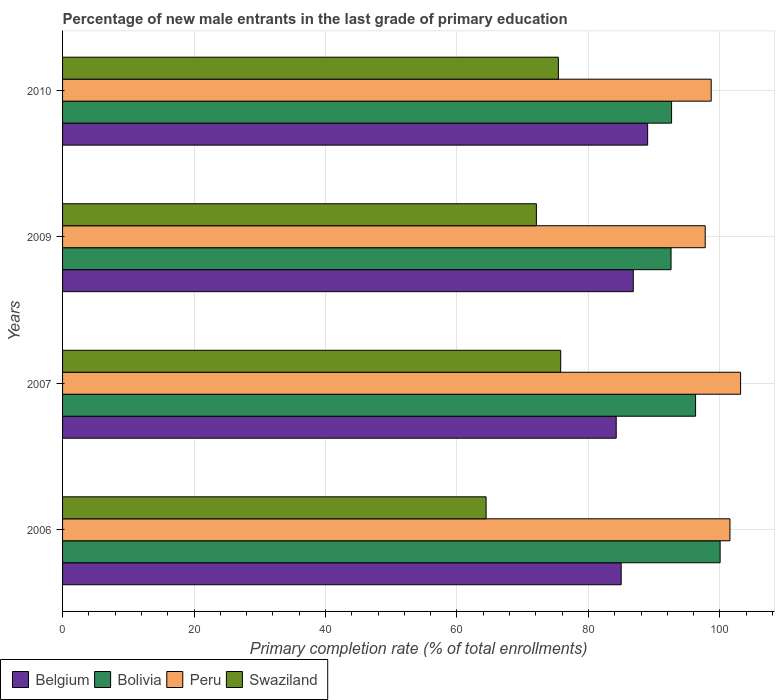How many bars are there on the 1st tick from the top?
Keep it short and to the point. 4. In how many cases, is the number of bars for a given year not equal to the number of legend labels?
Your response must be concise. 0. What is the percentage of new male entrants in Belgium in 2007?
Make the answer very short. 84.23. Across all years, what is the maximum percentage of new male entrants in Swaziland?
Provide a short and direct response. 75.78. Across all years, what is the minimum percentage of new male entrants in Swaziland?
Offer a very short reply. 64.43. What is the total percentage of new male entrants in Bolivia in the graph?
Make the answer very short. 381.57. What is the difference between the percentage of new male entrants in Swaziland in 2006 and that in 2010?
Keep it short and to the point. -11. What is the difference between the percentage of new male entrants in Swaziland in 2010 and the percentage of new male entrants in Belgium in 2009?
Offer a very short reply. -11.4. What is the average percentage of new male entrants in Swaziland per year?
Ensure brevity in your answer.  71.93. In the year 2006, what is the difference between the percentage of new male entrants in Bolivia and percentage of new male entrants in Swaziland?
Your answer should be compact. 35.61. What is the ratio of the percentage of new male entrants in Bolivia in 2007 to that in 2010?
Ensure brevity in your answer.  1.04. Is the percentage of new male entrants in Belgium in 2007 less than that in 2009?
Offer a terse response. Yes. What is the difference between the highest and the second highest percentage of new male entrants in Belgium?
Provide a short and direct response. 2.19. What is the difference between the highest and the lowest percentage of new male entrants in Peru?
Provide a succinct answer. 5.38. In how many years, is the percentage of new male entrants in Swaziland greater than the average percentage of new male entrants in Swaziland taken over all years?
Your response must be concise. 3. What does the 1st bar from the top in 2009 represents?
Ensure brevity in your answer.  Swaziland. Is it the case that in every year, the sum of the percentage of new male entrants in Belgium and percentage of new male entrants in Peru is greater than the percentage of new male entrants in Swaziland?
Offer a very short reply. Yes. Are all the bars in the graph horizontal?
Ensure brevity in your answer.  Yes. What is the difference between two consecutive major ticks on the X-axis?
Your answer should be compact. 20. How many legend labels are there?
Your answer should be very brief. 4. What is the title of the graph?
Your answer should be compact. Percentage of new male entrants in the last grade of primary education. Does "French Polynesia" appear as one of the legend labels in the graph?
Give a very brief answer. No. What is the label or title of the X-axis?
Offer a very short reply. Primary completion rate (% of total enrollments). What is the label or title of the Y-axis?
Offer a terse response. Years. What is the Primary completion rate (% of total enrollments) in Belgium in 2006?
Your response must be concise. 84.99. What is the Primary completion rate (% of total enrollments) in Bolivia in 2006?
Offer a very short reply. 100.04. What is the Primary completion rate (% of total enrollments) of Peru in 2006?
Provide a succinct answer. 101.53. What is the Primary completion rate (% of total enrollments) of Swaziland in 2006?
Offer a terse response. 64.43. What is the Primary completion rate (% of total enrollments) in Belgium in 2007?
Keep it short and to the point. 84.23. What is the Primary completion rate (% of total enrollments) in Bolivia in 2007?
Your response must be concise. 96.3. What is the Primary completion rate (% of total enrollments) in Peru in 2007?
Your response must be concise. 103.15. What is the Primary completion rate (% of total enrollments) of Swaziland in 2007?
Your response must be concise. 75.78. What is the Primary completion rate (% of total enrollments) in Belgium in 2009?
Offer a terse response. 86.83. What is the Primary completion rate (% of total enrollments) of Bolivia in 2009?
Your answer should be compact. 92.57. What is the Primary completion rate (% of total enrollments) in Peru in 2009?
Ensure brevity in your answer.  97.77. What is the Primary completion rate (% of total enrollments) in Swaziland in 2009?
Offer a terse response. 72.08. What is the Primary completion rate (% of total enrollments) in Belgium in 2010?
Keep it short and to the point. 89.01. What is the Primary completion rate (% of total enrollments) of Bolivia in 2010?
Your answer should be compact. 92.65. What is the Primary completion rate (% of total enrollments) in Peru in 2010?
Your answer should be compact. 98.68. What is the Primary completion rate (% of total enrollments) in Swaziland in 2010?
Your answer should be very brief. 75.43. Across all years, what is the maximum Primary completion rate (% of total enrollments) of Belgium?
Offer a very short reply. 89.01. Across all years, what is the maximum Primary completion rate (% of total enrollments) of Bolivia?
Provide a short and direct response. 100.04. Across all years, what is the maximum Primary completion rate (% of total enrollments) in Peru?
Offer a terse response. 103.15. Across all years, what is the maximum Primary completion rate (% of total enrollments) in Swaziland?
Offer a terse response. 75.78. Across all years, what is the minimum Primary completion rate (% of total enrollments) of Belgium?
Your answer should be very brief. 84.23. Across all years, what is the minimum Primary completion rate (% of total enrollments) of Bolivia?
Give a very brief answer. 92.57. Across all years, what is the minimum Primary completion rate (% of total enrollments) of Peru?
Offer a terse response. 97.77. Across all years, what is the minimum Primary completion rate (% of total enrollments) in Swaziland?
Provide a succinct answer. 64.43. What is the total Primary completion rate (% of total enrollments) of Belgium in the graph?
Provide a succinct answer. 345.06. What is the total Primary completion rate (% of total enrollments) in Bolivia in the graph?
Ensure brevity in your answer.  381.56. What is the total Primary completion rate (% of total enrollments) of Peru in the graph?
Provide a succinct answer. 401.13. What is the total Primary completion rate (% of total enrollments) in Swaziland in the graph?
Give a very brief answer. 287.73. What is the difference between the Primary completion rate (% of total enrollments) of Belgium in 2006 and that in 2007?
Make the answer very short. 0.76. What is the difference between the Primary completion rate (% of total enrollments) of Bolivia in 2006 and that in 2007?
Your answer should be very brief. 3.74. What is the difference between the Primary completion rate (% of total enrollments) in Peru in 2006 and that in 2007?
Your answer should be very brief. -1.62. What is the difference between the Primary completion rate (% of total enrollments) in Swaziland in 2006 and that in 2007?
Ensure brevity in your answer.  -11.35. What is the difference between the Primary completion rate (% of total enrollments) in Belgium in 2006 and that in 2009?
Your response must be concise. -1.84. What is the difference between the Primary completion rate (% of total enrollments) of Bolivia in 2006 and that in 2009?
Make the answer very short. 7.47. What is the difference between the Primary completion rate (% of total enrollments) of Peru in 2006 and that in 2009?
Your answer should be compact. 3.76. What is the difference between the Primary completion rate (% of total enrollments) of Swaziland in 2006 and that in 2009?
Make the answer very short. -7.65. What is the difference between the Primary completion rate (% of total enrollments) of Belgium in 2006 and that in 2010?
Ensure brevity in your answer.  -4.03. What is the difference between the Primary completion rate (% of total enrollments) of Bolivia in 2006 and that in 2010?
Your answer should be very brief. 7.39. What is the difference between the Primary completion rate (% of total enrollments) of Peru in 2006 and that in 2010?
Offer a very short reply. 2.85. What is the difference between the Primary completion rate (% of total enrollments) in Swaziland in 2006 and that in 2010?
Keep it short and to the point. -11. What is the difference between the Primary completion rate (% of total enrollments) of Belgium in 2007 and that in 2009?
Your answer should be compact. -2.59. What is the difference between the Primary completion rate (% of total enrollments) in Bolivia in 2007 and that in 2009?
Keep it short and to the point. 3.73. What is the difference between the Primary completion rate (% of total enrollments) of Peru in 2007 and that in 2009?
Your answer should be compact. 5.38. What is the difference between the Primary completion rate (% of total enrollments) of Swaziland in 2007 and that in 2009?
Offer a very short reply. 3.7. What is the difference between the Primary completion rate (% of total enrollments) of Belgium in 2007 and that in 2010?
Provide a short and direct response. -4.78. What is the difference between the Primary completion rate (% of total enrollments) of Bolivia in 2007 and that in 2010?
Offer a very short reply. 3.65. What is the difference between the Primary completion rate (% of total enrollments) in Peru in 2007 and that in 2010?
Your answer should be very brief. 4.47. What is the difference between the Primary completion rate (% of total enrollments) of Swaziland in 2007 and that in 2010?
Keep it short and to the point. 0.35. What is the difference between the Primary completion rate (% of total enrollments) in Belgium in 2009 and that in 2010?
Give a very brief answer. -2.19. What is the difference between the Primary completion rate (% of total enrollments) of Bolivia in 2009 and that in 2010?
Offer a terse response. -0.08. What is the difference between the Primary completion rate (% of total enrollments) of Peru in 2009 and that in 2010?
Your answer should be compact. -0.91. What is the difference between the Primary completion rate (% of total enrollments) of Swaziland in 2009 and that in 2010?
Your response must be concise. -3.35. What is the difference between the Primary completion rate (% of total enrollments) of Belgium in 2006 and the Primary completion rate (% of total enrollments) of Bolivia in 2007?
Your response must be concise. -11.32. What is the difference between the Primary completion rate (% of total enrollments) of Belgium in 2006 and the Primary completion rate (% of total enrollments) of Peru in 2007?
Offer a terse response. -18.17. What is the difference between the Primary completion rate (% of total enrollments) in Belgium in 2006 and the Primary completion rate (% of total enrollments) in Swaziland in 2007?
Provide a succinct answer. 9.2. What is the difference between the Primary completion rate (% of total enrollments) of Bolivia in 2006 and the Primary completion rate (% of total enrollments) of Peru in 2007?
Make the answer very short. -3.11. What is the difference between the Primary completion rate (% of total enrollments) in Bolivia in 2006 and the Primary completion rate (% of total enrollments) in Swaziland in 2007?
Keep it short and to the point. 24.26. What is the difference between the Primary completion rate (% of total enrollments) in Peru in 2006 and the Primary completion rate (% of total enrollments) in Swaziland in 2007?
Keep it short and to the point. 25.75. What is the difference between the Primary completion rate (% of total enrollments) of Belgium in 2006 and the Primary completion rate (% of total enrollments) of Bolivia in 2009?
Give a very brief answer. -7.59. What is the difference between the Primary completion rate (% of total enrollments) in Belgium in 2006 and the Primary completion rate (% of total enrollments) in Peru in 2009?
Offer a terse response. -12.78. What is the difference between the Primary completion rate (% of total enrollments) of Belgium in 2006 and the Primary completion rate (% of total enrollments) of Swaziland in 2009?
Your answer should be compact. 12.9. What is the difference between the Primary completion rate (% of total enrollments) in Bolivia in 2006 and the Primary completion rate (% of total enrollments) in Peru in 2009?
Ensure brevity in your answer.  2.27. What is the difference between the Primary completion rate (% of total enrollments) of Bolivia in 2006 and the Primary completion rate (% of total enrollments) of Swaziland in 2009?
Give a very brief answer. 27.95. What is the difference between the Primary completion rate (% of total enrollments) in Peru in 2006 and the Primary completion rate (% of total enrollments) in Swaziland in 2009?
Offer a very short reply. 29.45. What is the difference between the Primary completion rate (% of total enrollments) of Belgium in 2006 and the Primary completion rate (% of total enrollments) of Bolivia in 2010?
Ensure brevity in your answer.  -7.67. What is the difference between the Primary completion rate (% of total enrollments) of Belgium in 2006 and the Primary completion rate (% of total enrollments) of Peru in 2010?
Your response must be concise. -13.7. What is the difference between the Primary completion rate (% of total enrollments) of Belgium in 2006 and the Primary completion rate (% of total enrollments) of Swaziland in 2010?
Provide a succinct answer. 9.56. What is the difference between the Primary completion rate (% of total enrollments) in Bolivia in 2006 and the Primary completion rate (% of total enrollments) in Peru in 2010?
Ensure brevity in your answer.  1.36. What is the difference between the Primary completion rate (% of total enrollments) in Bolivia in 2006 and the Primary completion rate (% of total enrollments) in Swaziland in 2010?
Keep it short and to the point. 24.61. What is the difference between the Primary completion rate (% of total enrollments) in Peru in 2006 and the Primary completion rate (% of total enrollments) in Swaziland in 2010?
Provide a succinct answer. 26.1. What is the difference between the Primary completion rate (% of total enrollments) in Belgium in 2007 and the Primary completion rate (% of total enrollments) in Bolivia in 2009?
Keep it short and to the point. -8.34. What is the difference between the Primary completion rate (% of total enrollments) in Belgium in 2007 and the Primary completion rate (% of total enrollments) in Peru in 2009?
Your response must be concise. -13.54. What is the difference between the Primary completion rate (% of total enrollments) in Belgium in 2007 and the Primary completion rate (% of total enrollments) in Swaziland in 2009?
Provide a short and direct response. 12.15. What is the difference between the Primary completion rate (% of total enrollments) of Bolivia in 2007 and the Primary completion rate (% of total enrollments) of Peru in 2009?
Your answer should be compact. -1.47. What is the difference between the Primary completion rate (% of total enrollments) in Bolivia in 2007 and the Primary completion rate (% of total enrollments) in Swaziland in 2009?
Ensure brevity in your answer.  24.22. What is the difference between the Primary completion rate (% of total enrollments) of Peru in 2007 and the Primary completion rate (% of total enrollments) of Swaziland in 2009?
Make the answer very short. 31.07. What is the difference between the Primary completion rate (% of total enrollments) in Belgium in 2007 and the Primary completion rate (% of total enrollments) in Bolivia in 2010?
Ensure brevity in your answer.  -8.42. What is the difference between the Primary completion rate (% of total enrollments) in Belgium in 2007 and the Primary completion rate (% of total enrollments) in Peru in 2010?
Offer a terse response. -14.45. What is the difference between the Primary completion rate (% of total enrollments) in Belgium in 2007 and the Primary completion rate (% of total enrollments) in Swaziland in 2010?
Keep it short and to the point. 8.8. What is the difference between the Primary completion rate (% of total enrollments) of Bolivia in 2007 and the Primary completion rate (% of total enrollments) of Peru in 2010?
Offer a very short reply. -2.38. What is the difference between the Primary completion rate (% of total enrollments) of Bolivia in 2007 and the Primary completion rate (% of total enrollments) of Swaziland in 2010?
Your answer should be compact. 20.87. What is the difference between the Primary completion rate (% of total enrollments) of Peru in 2007 and the Primary completion rate (% of total enrollments) of Swaziland in 2010?
Provide a succinct answer. 27.72. What is the difference between the Primary completion rate (% of total enrollments) of Belgium in 2009 and the Primary completion rate (% of total enrollments) of Bolivia in 2010?
Your response must be concise. -5.83. What is the difference between the Primary completion rate (% of total enrollments) of Belgium in 2009 and the Primary completion rate (% of total enrollments) of Peru in 2010?
Provide a short and direct response. -11.86. What is the difference between the Primary completion rate (% of total enrollments) in Belgium in 2009 and the Primary completion rate (% of total enrollments) in Swaziland in 2010?
Keep it short and to the point. 11.4. What is the difference between the Primary completion rate (% of total enrollments) of Bolivia in 2009 and the Primary completion rate (% of total enrollments) of Peru in 2010?
Keep it short and to the point. -6.11. What is the difference between the Primary completion rate (% of total enrollments) of Bolivia in 2009 and the Primary completion rate (% of total enrollments) of Swaziland in 2010?
Give a very brief answer. 17.14. What is the difference between the Primary completion rate (% of total enrollments) of Peru in 2009 and the Primary completion rate (% of total enrollments) of Swaziland in 2010?
Ensure brevity in your answer.  22.34. What is the average Primary completion rate (% of total enrollments) in Belgium per year?
Ensure brevity in your answer.  86.26. What is the average Primary completion rate (% of total enrollments) of Bolivia per year?
Your answer should be very brief. 95.39. What is the average Primary completion rate (% of total enrollments) of Peru per year?
Offer a terse response. 100.28. What is the average Primary completion rate (% of total enrollments) in Swaziland per year?
Provide a short and direct response. 71.93. In the year 2006, what is the difference between the Primary completion rate (% of total enrollments) of Belgium and Primary completion rate (% of total enrollments) of Bolivia?
Offer a terse response. -15.05. In the year 2006, what is the difference between the Primary completion rate (% of total enrollments) in Belgium and Primary completion rate (% of total enrollments) in Peru?
Provide a succinct answer. -16.55. In the year 2006, what is the difference between the Primary completion rate (% of total enrollments) of Belgium and Primary completion rate (% of total enrollments) of Swaziland?
Your answer should be compact. 20.55. In the year 2006, what is the difference between the Primary completion rate (% of total enrollments) in Bolivia and Primary completion rate (% of total enrollments) in Peru?
Provide a short and direct response. -1.49. In the year 2006, what is the difference between the Primary completion rate (% of total enrollments) of Bolivia and Primary completion rate (% of total enrollments) of Swaziland?
Offer a very short reply. 35.61. In the year 2006, what is the difference between the Primary completion rate (% of total enrollments) in Peru and Primary completion rate (% of total enrollments) in Swaziland?
Ensure brevity in your answer.  37.1. In the year 2007, what is the difference between the Primary completion rate (% of total enrollments) in Belgium and Primary completion rate (% of total enrollments) in Bolivia?
Your answer should be compact. -12.07. In the year 2007, what is the difference between the Primary completion rate (% of total enrollments) in Belgium and Primary completion rate (% of total enrollments) in Peru?
Ensure brevity in your answer.  -18.92. In the year 2007, what is the difference between the Primary completion rate (% of total enrollments) of Belgium and Primary completion rate (% of total enrollments) of Swaziland?
Make the answer very short. 8.45. In the year 2007, what is the difference between the Primary completion rate (% of total enrollments) in Bolivia and Primary completion rate (% of total enrollments) in Peru?
Keep it short and to the point. -6.85. In the year 2007, what is the difference between the Primary completion rate (% of total enrollments) in Bolivia and Primary completion rate (% of total enrollments) in Swaziland?
Keep it short and to the point. 20.52. In the year 2007, what is the difference between the Primary completion rate (% of total enrollments) of Peru and Primary completion rate (% of total enrollments) of Swaziland?
Provide a succinct answer. 27.37. In the year 2009, what is the difference between the Primary completion rate (% of total enrollments) in Belgium and Primary completion rate (% of total enrollments) in Bolivia?
Your answer should be very brief. -5.75. In the year 2009, what is the difference between the Primary completion rate (% of total enrollments) in Belgium and Primary completion rate (% of total enrollments) in Peru?
Your answer should be compact. -10.94. In the year 2009, what is the difference between the Primary completion rate (% of total enrollments) of Belgium and Primary completion rate (% of total enrollments) of Swaziland?
Provide a short and direct response. 14.74. In the year 2009, what is the difference between the Primary completion rate (% of total enrollments) of Bolivia and Primary completion rate (% of total enrollments) of Peru?
Give a very brief answer. -5.2. In the year 2009, what is the difference between the Primary completion rate (% of total enrollments) of Bolivia and Primary completion rate (% of total enrollments) of Swaziland?
Your response must be concise. 20.49. In the year 2009, what is the difference between the Primary completion rate (% of total enrollments) of Peru and Primary completion rate (% of total enrollments) of Swaziland?
Your response must be concise. 25.68. In the year 2010, what is the difference between the Primary completion rate (% of total enrollments) of Belgium and Primary completion rate (% of total enrollments) of Bolivia?
Your answer should be compact. -3.64. In the year 2010, what is the difference between the Primary completion rate (% of total enrollments) in Belgium and Primary completion rate (% of total enrollments) in Peru?
Make the answer very short. -9.67. In the year 2010, what is the difference between the Primary completion rate (% of total enrollments) of Belgium and Primary completion rate (% of total enrollments) of Swaziland?
Provide a succinct answer. 13.58. In the year 2010, what is the difference between the Primary completion rate (% of total enrollments) in Bolivia and Primary completion rate (% of total enrollments) in Peru?
Your answer should be very brief. -6.03. In the year 2010, what is the difference between the Primary completion rate (% of total enrollments) of Bolivia and Primary completion rate (% of total enrollments) of Swaziland?
Ensure brevity in your answer.  17.22. In the year 2010, what is the difference between the Primary completion rate (% of total enrollments) in Peru and Primary completion rate (% of total enrollments) in Swaziland?
Your answer should be compact. 23.25. What is the ratio of the Primary completion rate (% of total enrollments) of Belgium in 2006 to that in 2007?
Offer a very short reply. 1.01. What is the ratio of the Primary completion rate (% of total enrollments) of Bolivia in 2006 to that in 2007?
Make the answer very short. 1.04. What is the ratio of the Primary completion rate (% of total enrollments) in Peru in 2006 to that in 2007?
Give a very brief answer. 0.98. What is the ratio of the Primary completion rate (% of total enrollments) of Swaziland in 2006 to that in 2007?
Offer a terse response. 0.85. What is the ratio of the Primary completion rate (% of total enrollments) in Belgium in 2006 to that in 2009?
Provide a succinct answer. 0.98. What is the ratio of the Primary completion rate (% of total enrollments) of Bolivia in 2006 to that in 2009?
Your response must be concise. 1.08. What is the ratio of the Primary completion rate (% of total enrollments) in Swaziland in 2006 to that in 2009?
Make the answer very short. 0.89. What is the ratio of the Primary completion rate (% of total enrollments) in Belgium in 2006 to that in 2010?
Provide a short and direct response. 0.95. What is the ratio of the Primary completion rate (% of total enrollments) of Bolivia in 2006 to that in 2010?
Make the answer very short. 1.08. What is the ratio of the Primary completion rate (% of total enrollments) of Peru in 2006 to that in 2010?
Give a very brief answer. 1.03. What is the ratio of the Primary completion rate (% of total enrollments) of Swaziland in 2006 to that in 2010?
Your answer should be very brief. 0.85. What is the ratio of the Primary completion rate (% of total enrollments) of Belgium in 2007 to that in 2009?
Give a very brief answer. 0.97. What is the ratio of the Primary completion rate (% of total enrollments) of Bolivia in 2007 to that in 2009?
Make the answer very short. 1.04. What is the ratio of the Primary completion rate (% of total enrollments) in Peru in 2007 to that in 2009?
Provide a succinct answer. 1.06. What is the ratio of the Primary completion rate (% of total enrollments) of Swaziland in 2007 to that in 2009?
Provide a short and direct response. 1.05. What is the ratio of the Primary completion rate (% of total enrollments) in Belgium in 2007 to that in 2010?
Your answer should be compact. 0.95. What is the ratio of the Primary completion rate (% of total enrollments) in Bolivia in 2007 to that in 2010?
Offer a very short reply. 1.04. What is the ratio of the Primary completion rate (% of total enrollments) in Peru in 2007 to that in 2010?
Your answer should be very brief. 1.05. What is the ratio of the Primary completion rate (% of total enrollments) in Belgium in 2009 to that in 2010?
Your answer should be compact. 0.98. What is the ratio of the Primary completion rate (% of total enrollments) in Bolivia in 2009 to that in 2010?
Provide a succinct answer. 1. What is the ratio of the Primary completion rate (% of total enrollments) in Swaziland in 2009 to that in 2010?
Offer a very short reply. 0.96. What is the difference between the highest and the second highest Primary completion rate (% of total enrollments) in Belgium?
Ensure brevity in your answer.  2.19. What is the difference between the highest and the second highest Primary completion rate (% of total enrollments) in Bolivia?
Make the answer very short. 3.74. What is the difference between the highest and the second highest Primary completion rate (% of total enrollments) of Peru?
Make the answer very short. 1.62. What is the difference between the highest and the second highest Primary completion rate (% of total enrollments) of Swaziland?
Make the answer very short. 0.35. What is the difference between the highest and the lowest Primary completion rate (% of total enrollments) of Belgium?
Your answer should be very brief. 4.78. What is the difference between the highest and the lowest Primary completion rate (% of total enrollments) in Bolivia?
Offer a very short reply. 7.47. What is the difference between the highest and the lowest Primary completion rate (% of total enrollments) of Peru?
Offer a terse response. 5.38. What is the difference between the highest and the lowest Primary completion rate (% of total enrollments) in Swaziland?
Provide a succinct answer. 11.35. 